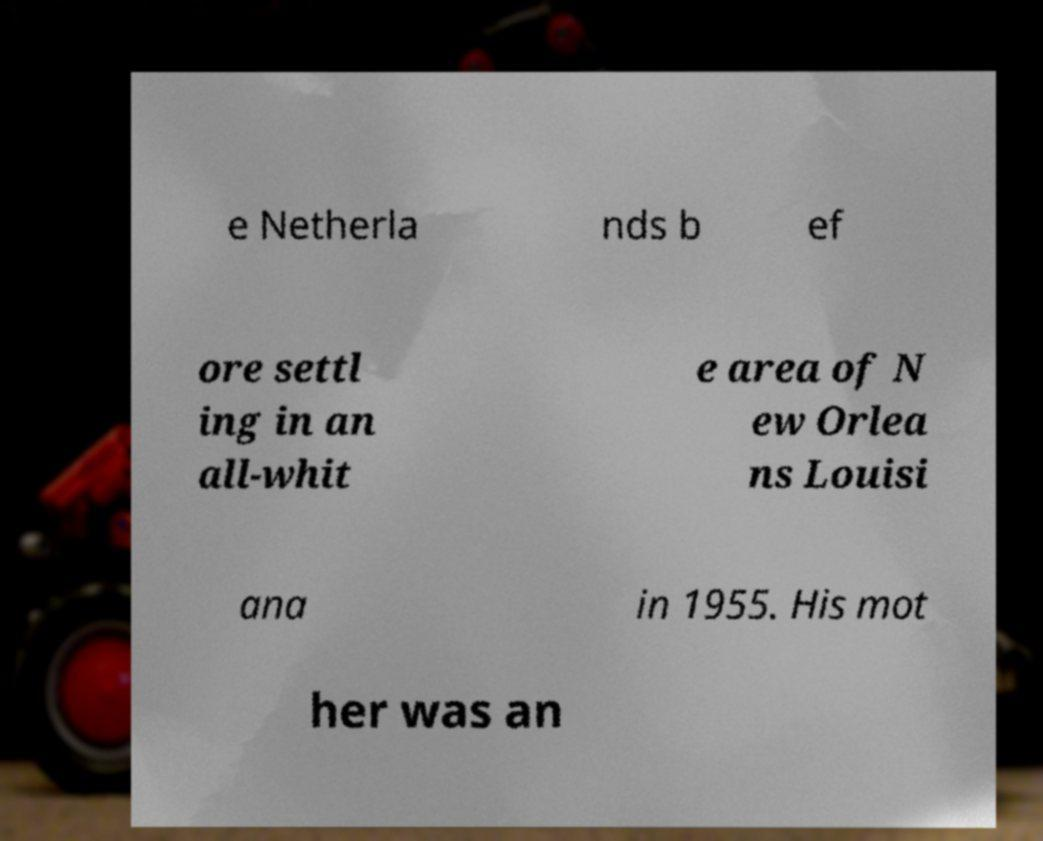Could you extract and type out the text from this image? e Netherla nds b ef ore settl ing in an all-whit e area of N ew Orlea ns Louisi ana in 1955. His mot her was an 